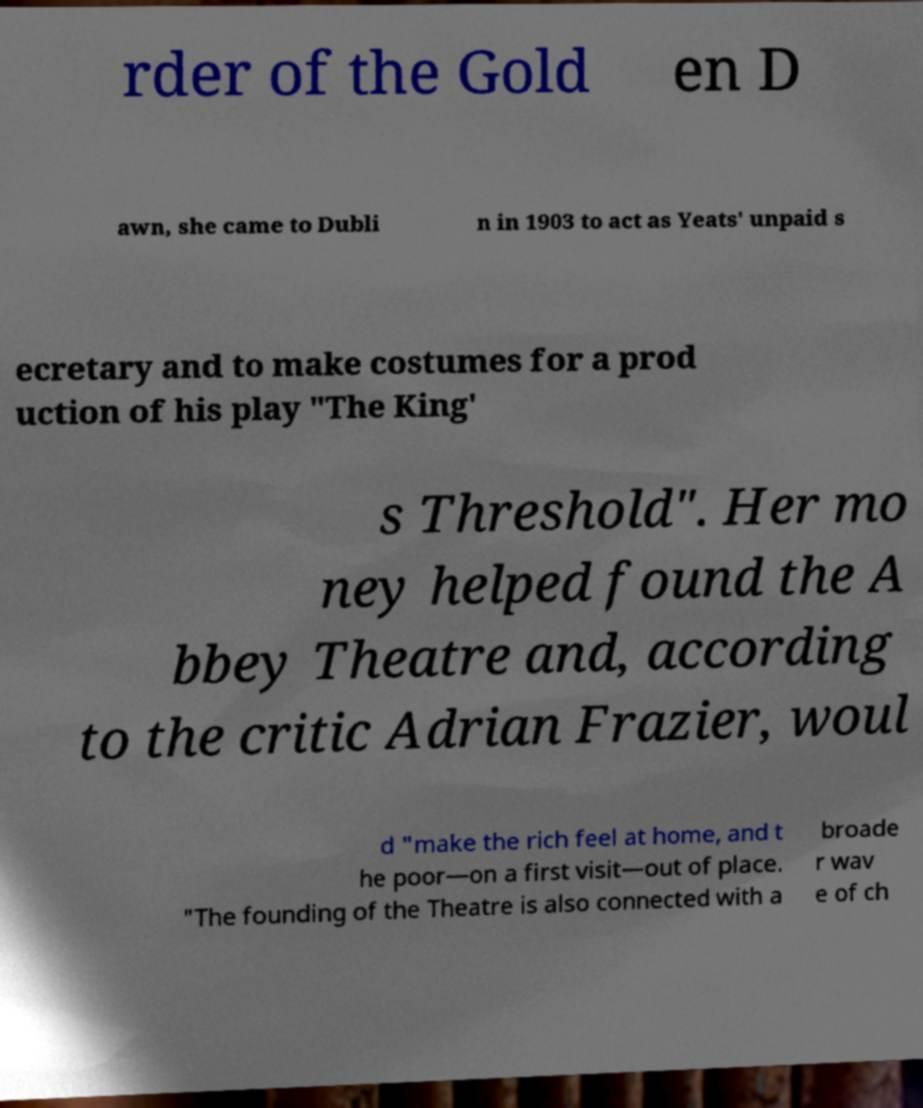Can you read and provide the text displayed in the image?This photo seems to have some interesting text. Can you extract and type it out for me? rder of the Gold en D awn, she came to Dubli n in 1903 to act as Yeats' unpaid s ecretary and to make costumes for a prod uction of his play "The King' s Threshold". Her mo ney helped found the A bbey Theatre and, according to the critic Adrian Frazier, woul d "make the rich feel at home, and t he poor—on a first visit—out of place. "The founding of the Theatre is also connected with a broade r wav e of ch 